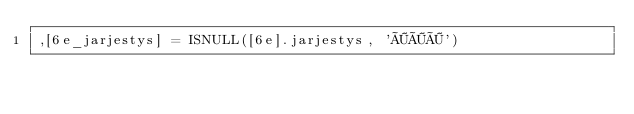Convert code to text. <code><loc_0><loc_0><loc_500><loc_500><_SQL_>,[6e_jarjestys] = ISNULL([6e].jarjestys, 'ÖÖÖ')</code> 